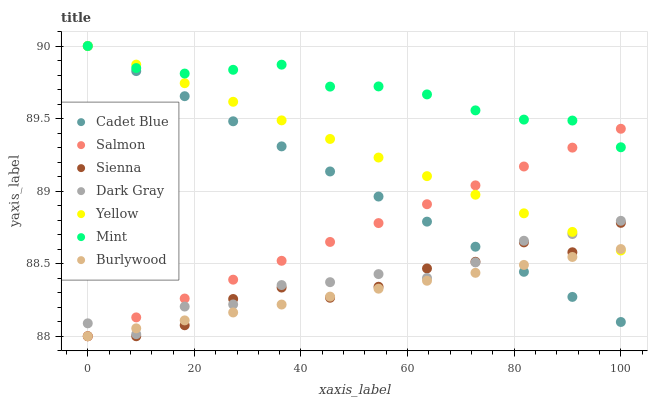Does Burlywood have the minimum area under the curve?
Answer yes or no. Yes. Does Mint have the maximum area under the curve?
Answer yes or no. Yes. Does Cadet Blue have the minimum area under the curve?
Answer yes or no. No. Does Cadet Blue have the maximum area under the curve?
Answer yes or no. No. Is Cadet Blue the smoothest?
Answer yes or no. Yes. Is Sienna the roughest?
Answer yes or no. Yes. Is Burlywood the smoothest?
Answer yes or no. No. Is Burlywood the roughest?
Answer yes or no. No. Does Burlywood have the lowest value?
Answer yes or no. Yes. Does Cadet Blue have the lowest value?
Answer yes or no. No. Does Mint have the highest value?
Answer yes or no. Yes. Does Burlywood have the highest value?
Answer yes or no. No. Is Burlywood less than Mint?
Answer yes or no. Yes. Is Mint greater than Burlywood?
Answer yes or no. Yes. Does Mint intersect Cadet Blue?
Answer yes or no. Yes. Is Mint less than Cadet Blue?
Answer yes or no. No. Is Mint greater than Cadet Blue?
Answer yes or no. No. Does Burlywood intersect Mint?
Answer yes or no. No. 